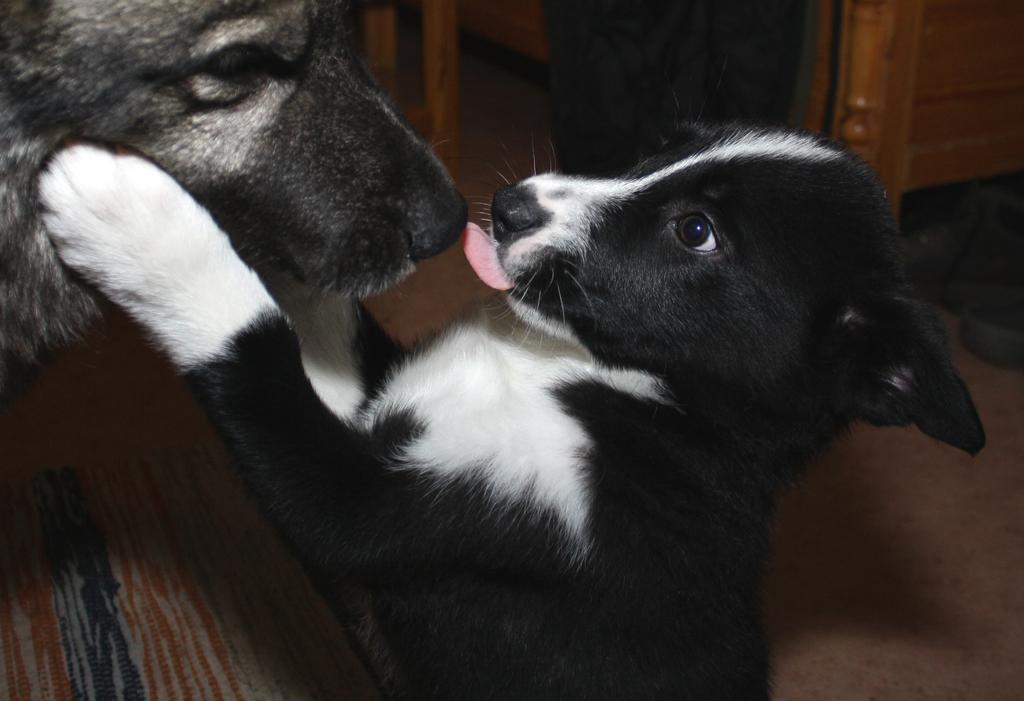In one or two sentences, can you explain what this image depicts? In this image there are two dogs, behind them, we can see the legs of a person and some wooden structures. 